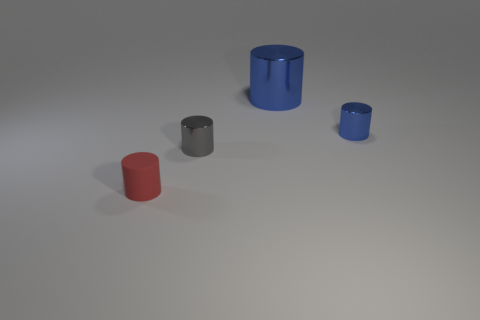What material is the small gray thing that is the same shape as the large blue thing?
Keep it short and to the point. Metal. The large object has what shape?
Your response must be concise. Cylinder. What is the object that is in front of the big blue cylinder and behind the small gray metal cylinder made of?
Give a very brief answer. Metal. What size is the gray cylinder that is made of the same material as the large object?
Provide a succinct answer. Small. The object that is both in front of the big blue cylinder and to the right of the small gray thing has what shape?
Keep it short and to the point. Cylinder. There is a object that is in front of the small metallic thing that is to the left of the tiny blue cylinder; what size is it?
Give a very brief answer. Small. How many other things are the same color as the tiny rubber cylinder?
Provide a short and direct response. 0. What material is the small blue object?
Your response must be concise. Metal. Are there any red rubber cylinders?
Offer a very short reply. Yes. Are there an equal number of large shiny things that are behind the large blue metallic thing and blue cylinders?
Make the answer very short. No. 